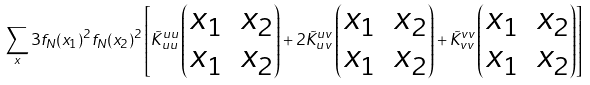Convert formula to latex. <formula><loc_0><loc_0><loc_500><loc_500>\sum _ { x } 3 f _ { N } ( x _ { 1 } ) ^ { 2 } f _ { N } ( x _ { 2 } ) ^ { 2 } \left [ \tilde { K } _ { u u } ^ { u u } \left ( \begin{matrix} x _ { 1 } & x _ { 2 } \\ x _ { 1 } & x _ { 2 } \end{matrix} \right ) + 2 \tilde { K } _ { u v } ^ { u v } \left ( \begin{matrix} x _ { 1 } & x _ { 2 } \\ x _ { 1 } & x _ { 2 } \end{matrix} \right ) + \tilde { K } _ { v v } ^ { v v } \left ( \begin{matrix} x _ { 1 } & x _ { 2 } \\ x _ { 1 } & x _ { 2 } \end{matrix} \right ) \right ]</formula> 